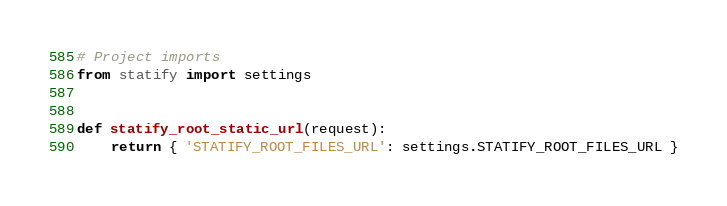Convert code to text. <code><loc_0><loc_0><loc_500><loc_500><_Python_># Project imports
from statify import settings


def statify_root_static_url(request):
    return { 'STATIFY_ROOT_FILES_URL': settings.STATIFY_ROOT_FILES_URL }
</code> 